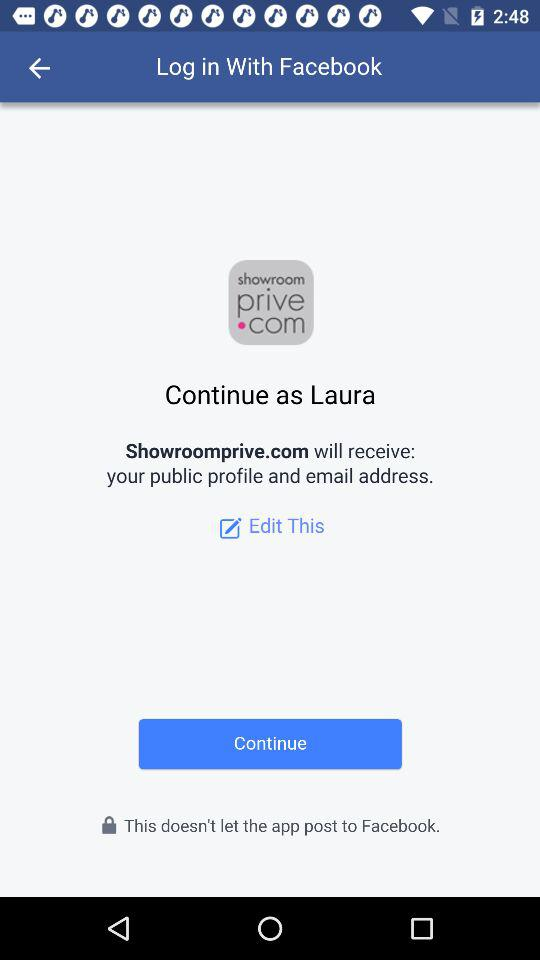What is the user name? The user name is Laura. 